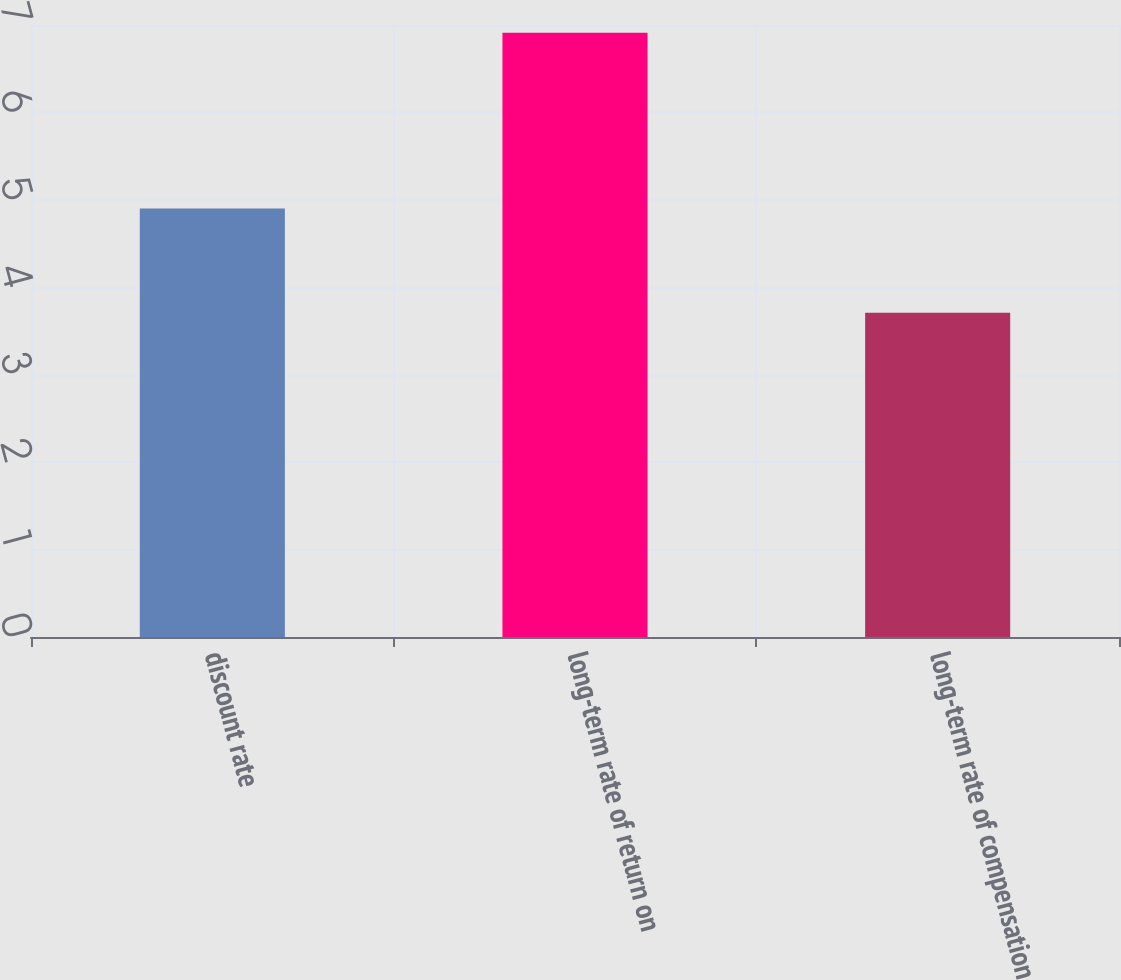<chart> <loc_0><loc_0><loc_500><loc_500><bar_chart><fcel>discount rate<fcel>long-term rate of return on<fcel>long-term rate of compensation<nl><fcel>4.9<fcel>6.91<fcel>3.71<nl></chart> 